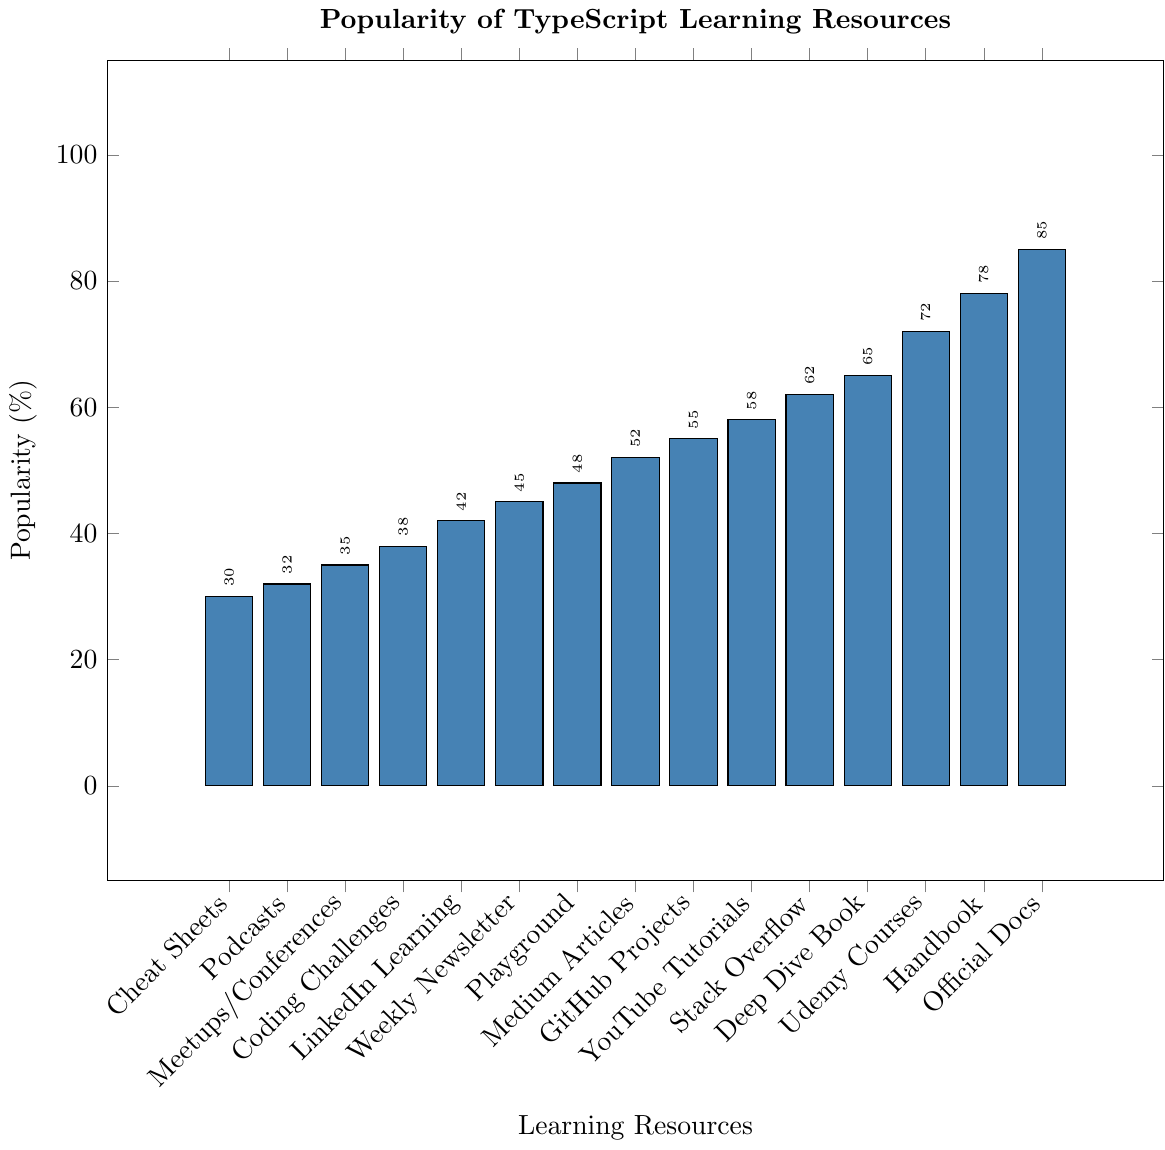Which TypeScript learning resource is the most popular? The first bar on the right represents the popularity of the "Official TypeScript Documentation," which is the tallest at 85%.
Answer: Official TypeScript Documentation Which resource is more popular, "Udemy TypeScript Courses" or "Medium TypeScript Articles"? "Udemy TypeScript Courses" has a bar height showing 72%, whereas "Medium TypeScript Articles" are at 52%.
Answer: Udemy TypeScript Courses What is the difference in popularity between the most and least popular resources? The most popular "Official TypeScript Documentation" has 85%, and the least popular "TypeScript Cheat Sheets" has 30%. The difference is 85% - 30% = 55%.
Answer: 55% Which TypeScript resource has around 45% popularity? The bar for "TypeScript Weekly Newsletter" aligns with the y-value of 45%.
Answer: TypeScript Weekly Newsletter What's the average popularity of the resources above 60%? The resources above 60% are "Official TypeScript Documentation" (85%), "TypeScript Handbook" (78%), "Udemy TypeScript Courses" (72%), "TypeScript Deep Dive Book" (65%), and "Stack Overflow TypeScript Questions" (62%). Their average is (85 + 78 + 72 + 65 + 62) / 5 = 72.4%.
Answer: 72.4% Is "GitHub TypeScript Projects" more popular than "TypeScript YouTube Tutorials"? The bar for "GitHub TypeScript Projects" is at 55%, and "TypeScript YouTube Tutorials" is at 58%. Therefore, "GitHub TypeScript Projects" is less popular.
Answer: No How many resources have a popularity of more than 50%? The resources with more than 50% are "Official TypeScript Documentation," "TypeScript Handbook," "Udemy TypeScript Courses," "TypeScript Deep Dive Book," "Stack Overflow TypeScript Questions," "TypeScript YouTube Tutorials," "GitHub TypeScript Projects," and "Medium TypeScript Articles." That's 8 resources in total.
Answer: 8 Compare the popularity difference between "TypeScript Coding Challenges" and "TypeScript Podcasts". "TypeScript Coding Challenges" have 38% popularity, and "TypeScript Podcasts" have 32%. The difference is 38% - 32% = 6%.
Answer: 6% Which resource is exactly in the middle in terms of popularity? Arrange the resources in descending order and find the middle: "LinkedIn Learning TypeScript Courses" with 42% is the 8th out of 15 resources, placing it in the middle.
Answer: LinkedIn Learning TypeScript Courses List the three least popular TypeScript learning resources. The shortest three bars correspond to "TypeScript Cheat Sheets" (30%), "TypeScript Podcasts" (32%), and "TypeScript Meetups/Conferences" (35%).
Answer: TypeScript Cheat Sheets, TypeScript Podcasts, TypeScript Meetups/Conferences 